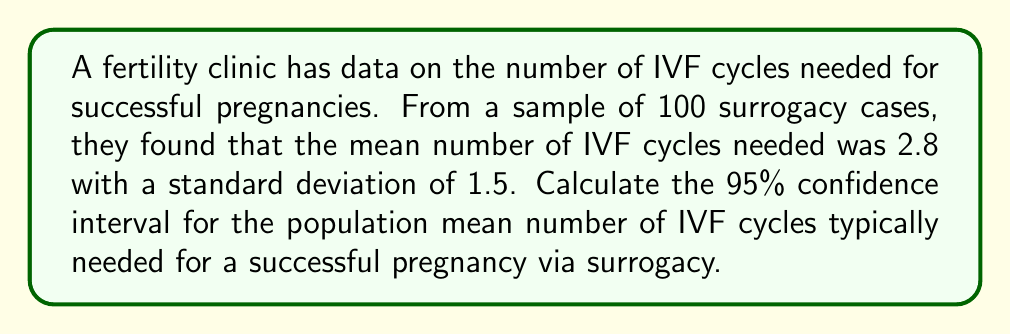Provide a solution to this math problem. To calculate the 95% confidence interval, we'll use the formula:

$$ \text{CI} = \bar{x} \pm t_{\alpha/2} \cdot \frac{s}{\sqrt{n}} $$

Where:
- $\bar{x}$ is the sample mean (2.8)
- $s$ is the sample standard deviation (1.5)
- $n$ is the sample size (100)
- $t_{\alpha/2}$ is the t-value for a 95% confidence level with 99 degrees of freedom

Steps:
1) Find $t_{\alpha/2}$: For a 95% CI with 99 df, $t_{\alpha/2} \approx 1.984$

2) Calculate the standard error (SE):
   $$ SE = \frac{s}{\sqrt{n}} = \frac{1.5}{\sqrt{100}} = 0.15 $$

3) Calculate the margin of error:
   $$ \text{Margin of Error} = t_{\alpha/2} \cdot SE = 1.984 \cdot 0.15 \approx 0.2976 $$

4) Calculate the confidence interval:
   $$ \text{CI} = 2.8 \pm 0.2976 $$
   $$ \text{CI} = (2.8 - 0.2976, 2.8 + 0.2976) $$
   $$ \text{CI} \approx (2.5024, 3.0976) $$
Answer: (2.50, 3.10) IVF cycles 